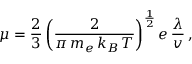<formula> <loc_0><loc_0><loc_500><loc_500>\mu = \frac { 2 } { 3 } \left ( \frac { 2 } { \pi \, m _ { e } \, k _ { B } \, T } \right ) ^ { \frac { 1 } { 2 } } e \, \frac { \lambda } { v } \, ,</formula> 